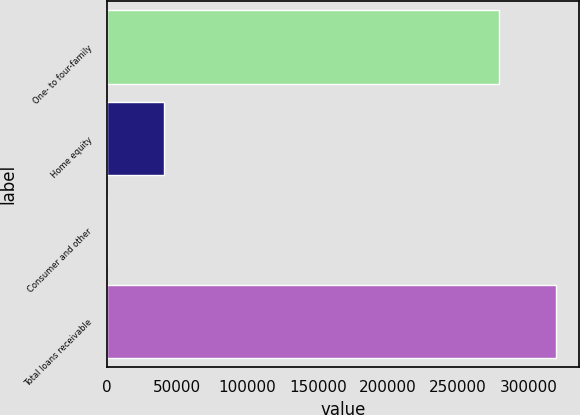Convert chart. <chart><loc_0><loc_0><loc_500><loc_500><bar_chart><fcel>One- to four-family<fcel>Home equity<fcel>Consumer and other<fcel>Total loans receivable<nl><fcel>278811<fcel>40939<fcel>195<fcel>319945<nl></chart> 